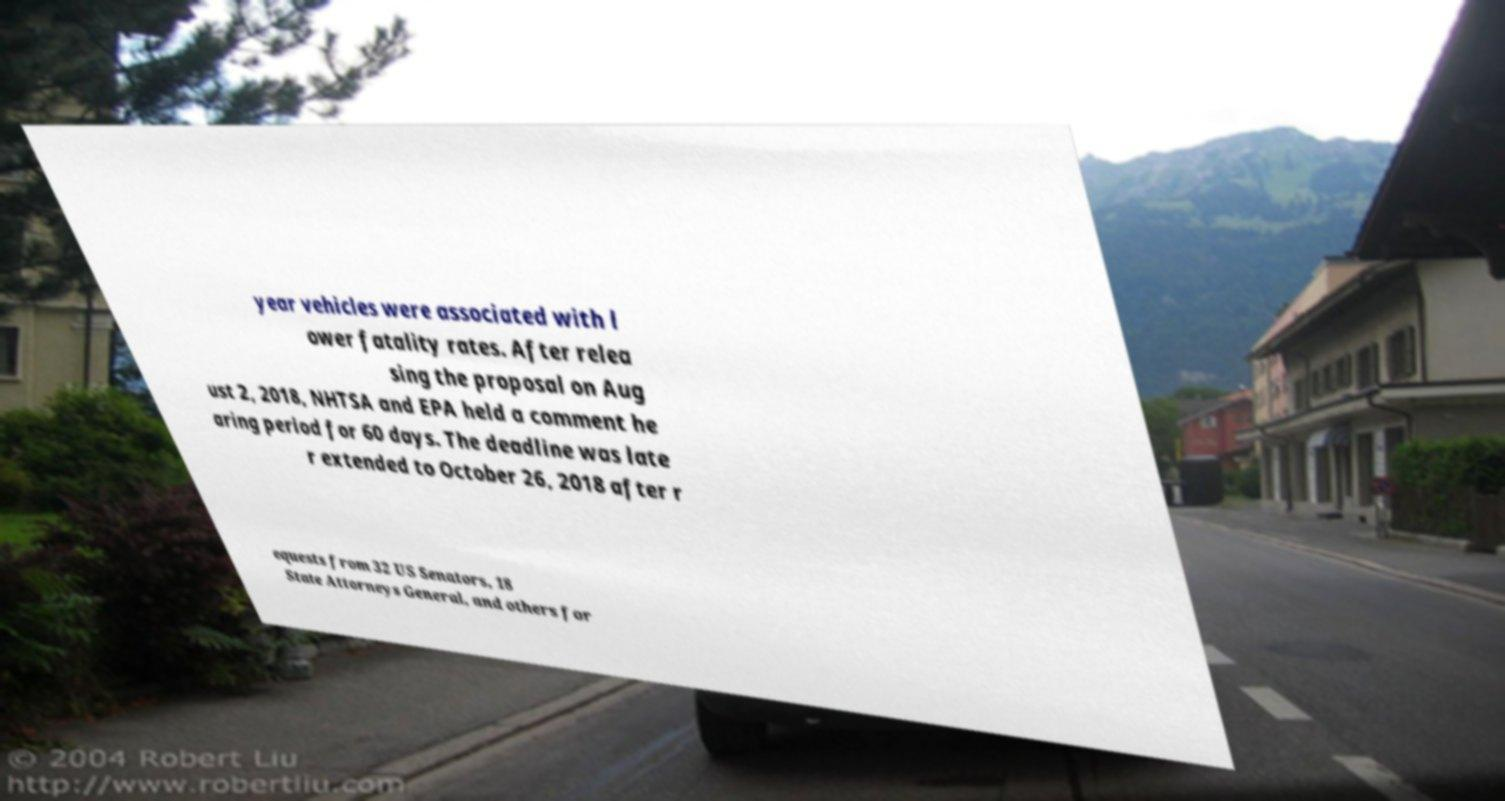Can you read and provide the text displayed in the image?This photo seems to have some interesting text. Can you extract and type it out for me? year vehicles were associated with l ower fatality rates. After relea sing the proposal on Aug ust 2, 2018, NHTSA and EPA held a comment he aring period for 60 days. The deadline was late r extended to October 26, 2018 after r equests from 32 US Senators, 18 State Attorneys General, and others for 